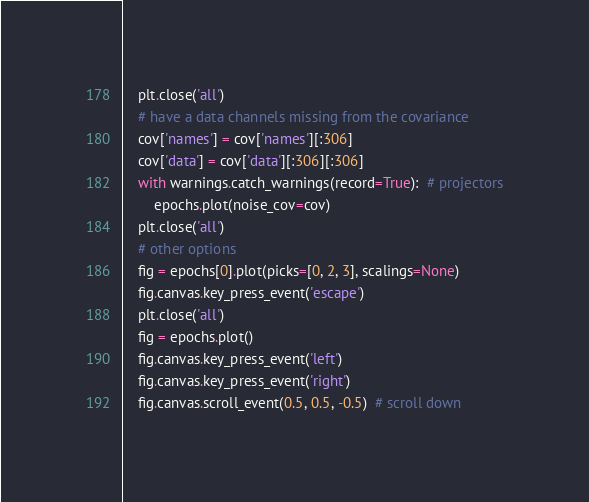<code> <loc_0><loc_0><loc_500><loc_500><_Python_>    plt.close('all')
    # have a data channels missing from the covariance
    cov['names'] = cov['names'][:306]
    cov['data'] = cov['data'][:306][:306]
    with warnings.catch_warnings(record=True):  # projectors
        epochs.plot(noise_cov=cov)
    plt.close('all')
    # other options
    fig = epochs[0].plot(picks=[0, 2, 3], scalings=None)
    fig.canvas.key_press_event('escape')
    plt.close('all')
    fig = epochs.plot()
    fig.canvas.key_press_event('left')
    fig.canvas.key_press_event('right')
    fig.canvas.scroll_event(0.5, 0.5, -0.5)  # scroll down</code> 